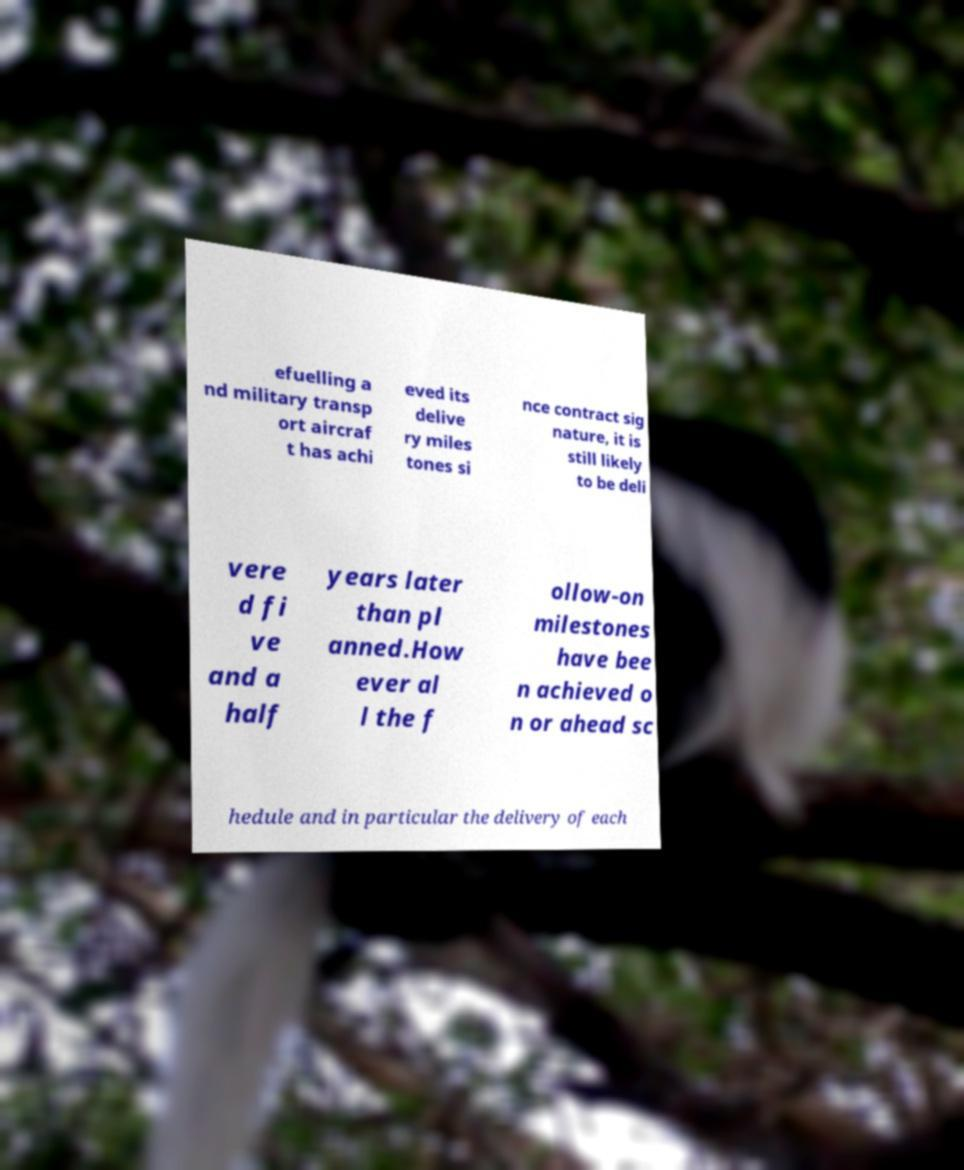There's text embedded in this image that I need extracted. Can you transcribe it verbatim? efuelling a nd military transp ort aircraf t has achi eved its delive ry miles tones si nce contract sig nature, it is still likely to be deli vere d fi ve and a half years later than pl anned.How ever al l the f ollow-on milestones have bee n achieved o n or ahead sc hedule and in particular the delivery of each 